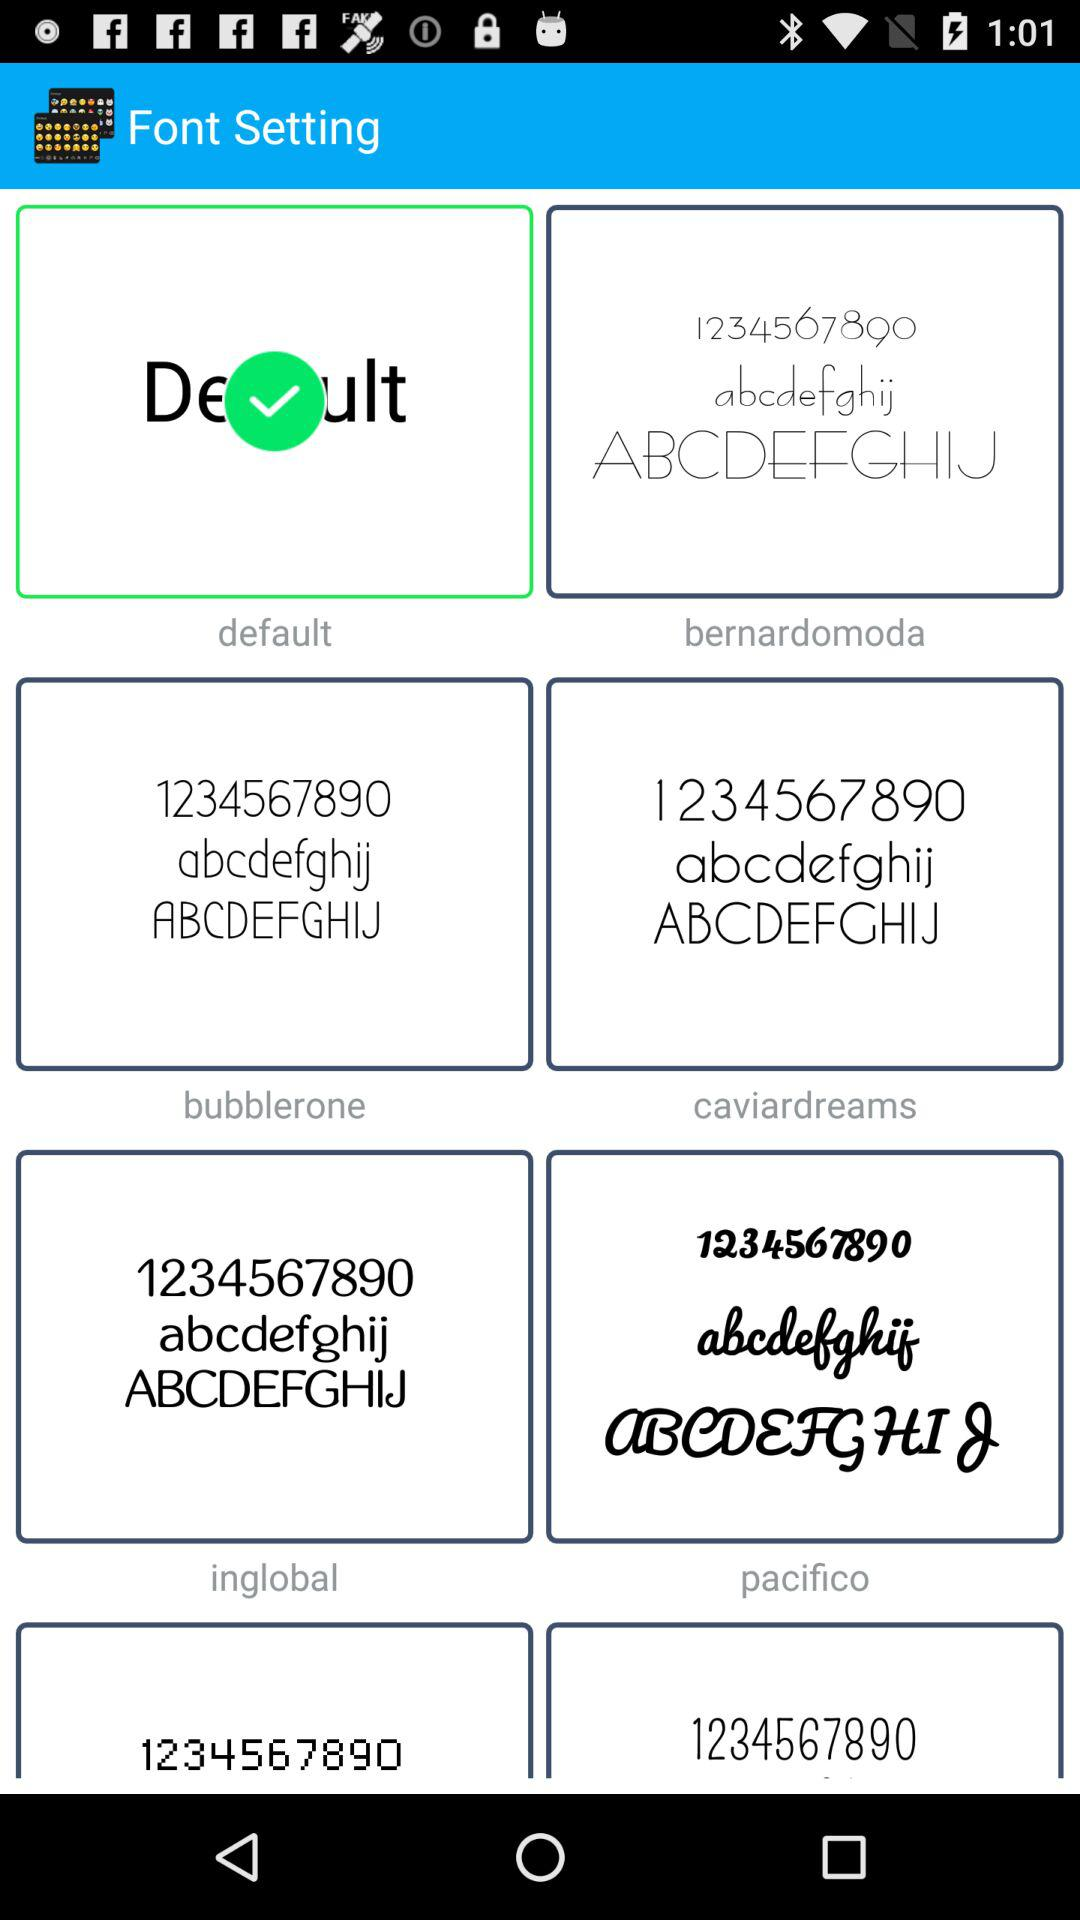Which option is selected? The selected option is "default". 